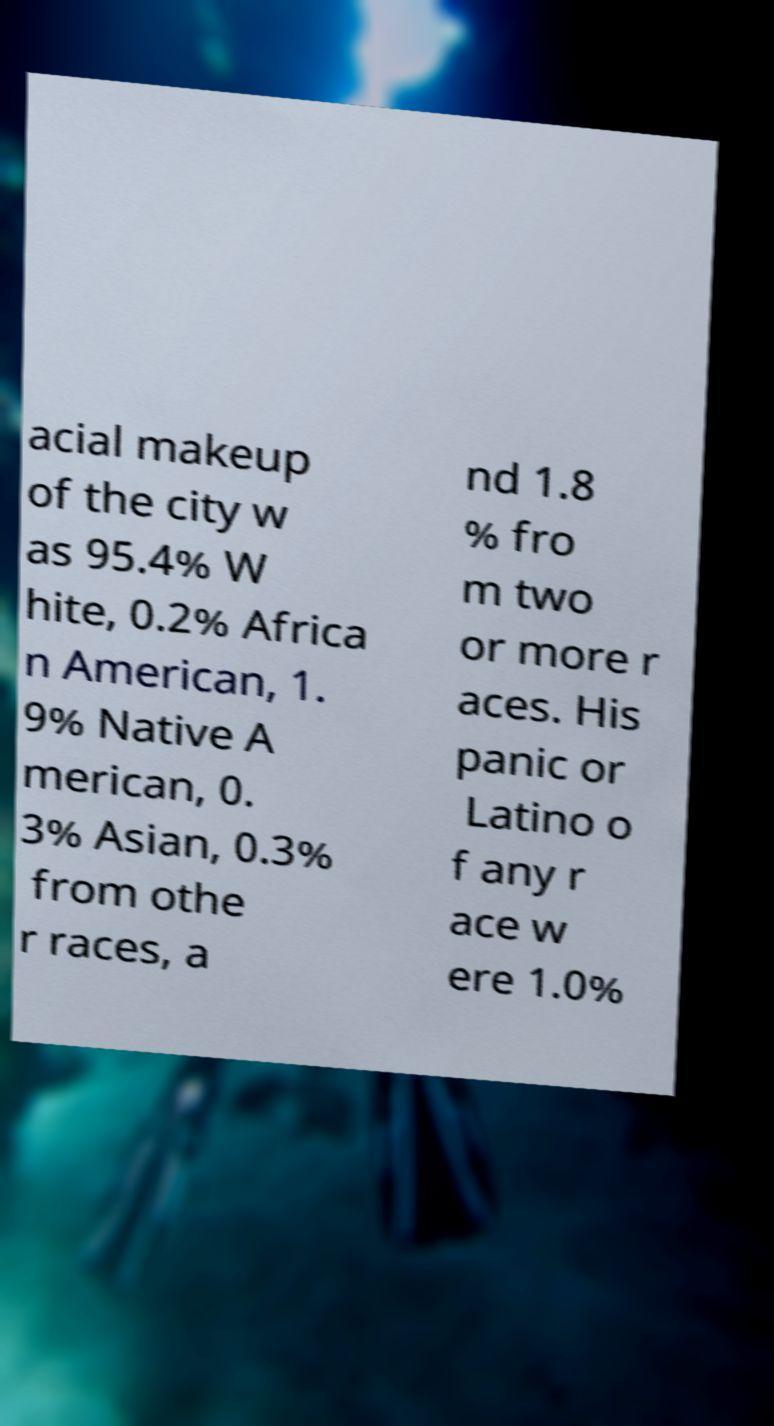Could you assist in decoding the text presented in this image and type it out clearly? acial makeup of the city w as 95.4% W hite, 0.2% Africa n American, 1. 9% Native A merican, 0. 3% Asian, 0.3% from othe r races, a nd 1.8 % fro m two or more r aces. His panic or Latino o f any r ace w ere 1.0% 